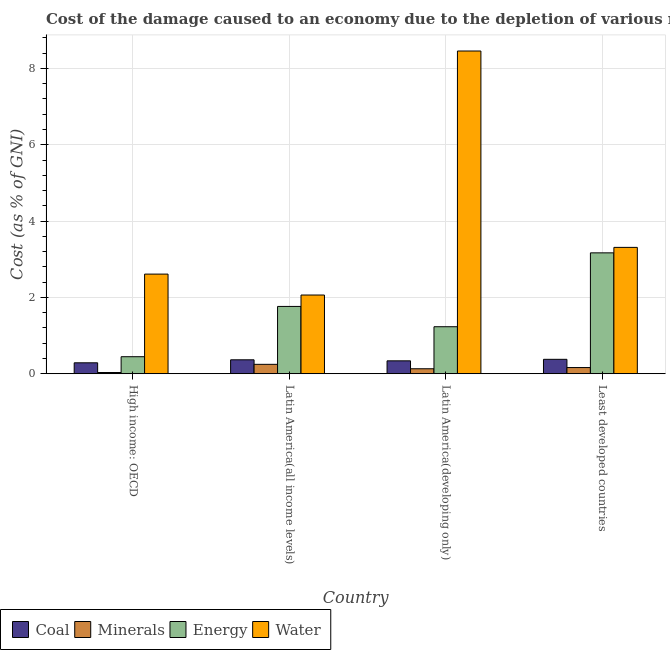How many different coloured bars are there?
Make the answer very short. 4. How many groups of bars are there?
Provide a succinct answer. 4. Are the number of bars on each tick of the X-axis equal?
Provide a short and direct response. Yes. How many bars are there on the 2nd tick from the left?
Make the answer very short. 4. How many bars are there on the 4th tick from the right?
Offer a terse response. 4. What is the label of the 2nd group of bars from the left?
Ensure brevity in your answer.  Latin America(all income levels). In how many cases, is the number of bars for a given country not equal to the number of legend labels?
Your response must be concise. 0. What is the cost of damage due to depletion of energy in Latin America(all income levels)?
Offer a very short reply. 1.76. Across all countries, what is the maximum cost of damage due to depletion of water?
Ensure brevity in your answer.  8.46. Across all countries, what is the minimum cost of damage due to depletion of minerals?
Your answer should be compact. 0.03. In which country was the cost of damage due to depletion of coal maximum?
Provide a succinct answer. Least developed countries. In which country was the cost of damage due to depletion of water minimum?
Your answer should be compact. Latin America(all income levels). What is the total cost of damage due to depletion of coal in the graph?
Offer a very short reply. 1.37. What is the difference between the cost of damage due to depletion of coal in High income: OECD and that in Least developed countries?
Provide a succinct answer. -0.09. What is the difference between the cost of damage due to depletion of minerals in Latin America(developing only) and the cost of damage due to depletion of water in Least developed countries?
Your answer should be compact. -3.18. What is the average cost of damage due to depletion of water per country?
Keep it short and to the point. 4.11. What is the difference between the cost of damage due to depletion of coal and cost of damage due to depletion of water in High income: OECD?
Your answer should be very brief. -2.32. In how many countries, is the cost of damage due to depletion of coal greater than 2 %?
Give a very brief answer. 0. What is the ratio of the cost of damage due to depletion of coal in Latin America(developing only) to that in Least developed countries?
Offer a very short reply. 0.89. What is the difference between the highest and the second highest cost of damage due to depletion of coal?
Offer a terse response. 0.01. What is the difference between the highest and the lowest cost of damage due to depletion of coal?
Your answer should be very brief. 0.09. In how many countries, is the cost of damage due to depletion of minerals greater than the average cost of damage due to depletion of minerals taken over all countries?
Offer a terse response. 2. Is it the case that in every country, the sum of the cost of damage due to depletion of coal and cost of damage due to depletion of minerals is greater than the sum of cost of damage due to depletion of energy and cost of damage due to depletion of water?
Give a very brief answer. No. What does the 3rd bar from the left in High income: OECD represents?
Keep it short and to the point. Energy. What does the 2nd bar from the right in Latin America(all income levels) represents?
Your answer should be very brief. Energy. Is it the case that in every country, the sum of the cost of damage due to depletion of coal and cost of damage due to depletion of minerals is greater than the cost of damage due to depletion of energy?
Make the answer very short. No. How many bars are there?
Your answer should be compact. 16. Does the graph contain any zero values?
Offer a very short reply. No. Where does the legend appear in the graph?
Your answer should be compact. Bottom left. How are the legend labels stacked?
Make the answer very short. Horizontal. What is the title of the graph?
Offer a terse response. Cost of the damage caused to an economy due to the depletion of various resources in 1996 . Does "Luxembourg" appear as one of the legend labels in the graph?
Your answer should be compact. No. What is the label or title of the X-axis?
Ensure brevity in your answer.  Country. What is the label or title of the Y-axis?
Your answer should be compact. Cost (as % of GNI). What is the Cost (as % of GNI) of Coal in High income: OECD?
Your answer should be very brief. 0.29. What is the Cost (as % of GNI) in Minerals in High income: OECD?
Offer a very short reply. 0.03. What is the Cost (as % of GNI) in Energy in High income: OECD?
Offer a very short reply. 0.45. What is the Cost (as % of GNI) of Water in High income: OECD?
Give a very brief answer. 2.61. What is the Cost (as % of GNI) in Coal in Latin America(all income levels)?
Make the answer very short. 0.37. What is the Cost (as % of GNI) in Minerals in Latin America(all income levels)?
Your response must be concise. 0.25. What is the Cost (as % of GNI) of Energy in Latin America(all income levels)?
Your answer should be very brief. 1.76. What is the Cost (as % of GNI) in Water in Latin America(all income levels)?
Your response must be concise. 2.06. What is the Cost (as % of GNI) of Coal in Latin America(developing only)?
Your answer should be compact. 0.34. What is the Cost (as % of GNI) of Minerals in Latin America(developing only)?
Provide a succinct answer. 0.13. What is the Cost (as % of GNI) of Energy in Latin America(developing only)?
Your response must be concise. 1.23. What is the Cost (as % of GNI) of Water in Latin America(developing only)?
Ensure brevity in your answer.  8.46. What is the Cost (as % of GNI) in Coal in Least developed countries?
Your answer should be very brief. 0.38. What is the Cost (as % of GNI) in Minerals in Least developed countries?
Your response must be concise. 0.16. What is the Cost (as % of GNI) in Energy in Least developed countries?
Provide a succinct answer. 3.17. What is the Cost (as % of GNI) in Water in Least developed countries?
Offer a very short reply. 3.31. Across all countries, what is the maximum Cost (as % of GNI) of Coal?
Provide a short and direct response. 0.38. Across all countries, what is the maximum Cost (as % of GNI) in Minerals?
Provide a succinct answer. 0.25. Across all countries, what is the maximum Cost (as % of GNI) of Energy?
Make the answer very short. 3.17. Across all countries, what is the maximum Cost (as % of GNI) of Water?
Offer a very short reply. 8.46. Across all countries, what is the minimum Cost (as % of GNI) of Coal?
Your response must be concise. 0.29. Across all countries, what is the minimum Cost (as % of GNI) in Minerals?
Offer a very short reply. 0.03. Across all countries, what is the minimum Cost (as % of GNI) of Energy?
Provide a short and direct response. 0.45. Across all countries, what is the minimum Cost (as % of GNI) in Water?
Your response must be concise. 2.06. What is the total Cost (as % of GNI) in Coal in the graph?
Offer a terse response. 1.37. What is the total Cost (as % of GNI) in Minerals in the graph?
Provide a short and direct response. 0.57. What is the total Cost (as % of GNI) in Energy in the graph?
Give a very brief answer. 6.61. What is the total Cost (as % of GNI) of Water in the graph?
Provide a succinct answer. 16.44. What is the difference between the Cost (as % of GNI) of Coal in High income: OECD and that in Latin America(all income levels)?
Offer a terse response. -0.08. What is the difference between the Cost (as % of GNI) of Minerals in High income: OECD and that in Latin America(all income levels)?
Ensure brevity in your answer.  -0.21. What is the difference between the Cost (as % of GNI) in Energy in High income: OECD and that in Latin America(all income levels)?
Your answer should be very brief. -1.32. What is the difference between the Cost (as % of GNI) of Water in High income: OECD and that in Latin America(all income levels)?
Your answer should be compact. 0.55. What is the difference between the Cost (as % of GNI) in Coal in High income: OECD and that in Latin America(developing only)?
Offer a terse response. -0.05. What is the difference between the Cost (as % of GNI) in Minerals in High income: OECD and that in Latin America(developing only)?
Offer a terse response. -0.1. What is the difference between the Cost (as % of GNI) in Energy in High income: OECD and that in Latin America(developing only)?
Your answer should be very brief. -0.79. What is the difference between the Cost (as % of GNI) in Water in High income: OECD and that in Latin America(developing only)?
Ensure brevity in your answer.  -5.85. What is the difference between the Cost (as % of GNI) in Coal in High income: OECD and that in Least developed countries?
Your answer should be compact. -0.09. What is the difference between the Cost (as % of GNI) of Minerals in High income: OECD and that in Least developed countries?
Provide a succinct answer. -0.13. What is the difference between the Cost (as % of GNI) in Energy in High income: OECD and that in Least developed countries?
Your answer should be compact. -2.72. What is the difference between the Cost (as % of GNI) of Water in High income: OECD and that in Least developed countries?
Make the answer very short. -0.7. What is the difference between the Cost (as % of GNI) of Coal in Latin America(all income levels) and that in Latin America(developing only)?
Offer a very short reply. 0.03. What is the difference between the Cost (as % of GNI) in Minerals in Latin America(all income levels) and that in Latin America(developing only)?
Your answer should be very brief. 0.12. What is the difference between the Cost (as % of GNI) of Energy in Latin America(all income levels) and that in Latin America(developing only)?
Give a very brief answer. 0.53. What is the difference between the Cost (as % of GNI) in Water in Latin America(all income levels) and that in Latin America(developing only)?
Ensure brevity in your answer.  -6.39. What is the difference between the Cost (as % of GNI) in Coal in Latin America(all income levels) and that in Least developed countries?
Your answer should be very brief. -0.01. What is the difference between the Cost (as % of GNI) of Minerals in Latin America(all income levels) and that in Least developed countries?
Your response must be concise. 0.08. What is the difference between the Cost (as % of GNI) of Energy in Latin America(all income levels) and that in Least developed countries?
Provide a succinct answer. -1.4. What is the difference between the Cost (as % of GNI) in Water in Latin America(all income levels) and that in Least developed countries?
Keep it short and to the point. -1.25. What is the difference between the Cost (as % of GNI) of Coal in Latin America(developing only) and that in Least developed countries?
Keep it short and to the point. -0.04. What is the difference between the Cost (as % of GNI) of Minerals in Latin America(developing only) and that in Least developed countries?
Your answer should be very brief. -0.03. What is the difference between the Cost (as % of GNI) of Energy in Latin America(developing only) and that in Least developed countries?
Your answer should be compact. -1.94. What is the difference between the Cost (as % of GNI) of Water in Latin America(developing only) and that in Least developed countries?
Provide a short and direct response. 5.15. What is the difference between the Cost (as % of GNI) of Coal in High income: OECD and the Cost (as % of GNI) of Minerals in Latin America(all income levels)?
Give a very brief answer. 0.04. What is the difference between the Cost (as % of GNI) of Coal in High income: OECD and the Cost (as % of GNI) of Energy in Latin America(all income levels)?
Offer a terse response. -1.48. What is the difference between the Cost (as % of GNI) in Coal in High income: OECD and the Cost (as % of GNI) in Water in Latin America(all income levels)?
Offer a very short reply. -1.78. What is the difference between the Cost (as % of GNI) in Minerals in High income: OECD and the Cost (as % of GNI) in Energy in Latin America(all income levels)?
Give a very brief answer. -1.73. What is the difference between the Cost (as % of GNI) of Minerals in High income: OECD and the Cost (as % of GNI) of Water in Latin America(all income levels)?
Provide a succinct answer. -2.03. What is the difference between the Cost (as % of GNI) in Energy in High income: OECD and the Cost (as % of GNI) in Water in Latin America(all income levels)?
Your response must be concise. -1.62. What is the difference between the Cost (as % of GNI) in Coal in High income: OECD and the Cost (as % of GNI) in Minerals in Latin America(developing only)?
Ensure brevity in your answer.  0.16. What is the difference between the Cost (as % of GNI) in Coal in High income: OECD and the Cost (as % of GNI) in Energy in Latin America(developing only)?
Your response must be concise. -0.95. What is the difference between the Cost (as % of GNI) in Coal in High income: OECD and the Cost (as % of GNI) in Water in Latin America(developing only)?
Offer a terse response. -8.17. What is the difference between the Cost (as % of GNI) in Minerals in High income: OECD and the Cost (as % of GNI) in Energy in Latin America(developing only)?
Your answer should be very brief. -1.2. What is the difference between the Cost (as % of GNI) of Minerals in High income: OECD and the Cost (as % of GNI) of Water in Latin America(developing only)?
Your response must be concise. -8.42. What is the difference between the Cost (as % of GNI) of Energy in High income: OECD and the Cost (as % of GNI) of Water in Latin America(developing only)?
Keep it short and to the point. -8.01. What is the difference between the Cost (as % of GNI) in Coal in High income: OECD and the Cost (as % of GNI) in Minerals in Least developed countries?
Offer a terse response. 0.12. What is the difference between the Cost (as % of GNI) in Coal in High income: OECD and the Cost (as % of GNI) in Energy in Least developed countries?
Provide a short and direct response. -2.88. What is the difference between the Cost (as % of GNI) of Coal in High income: OECD and the Cost (as % of GNI) of Water in Least developed countries?
Offer a very short reply. -3.02. What is the difference between the Cost (as % of GNI) in Minerals in High income: OECD and the Cost (as % of GNI) in Energy in Least developed countries?
Your response must be concise. -3.14. What is the difference between the Cost (as % of GNI) of Minerals in High income: OECD and the Cost (as % of GNI) of Water in Least developed countries?
Your answer should be compact. -3.28. What is the difference between the Cost (as % of GNI) in Energy in High income: OECD and the Cost (as % of GNI) in Water in Least developed countries?
Your response must be concise. -2.86. What is the difference between the Cost (as % of GNI) in Coal in Latin America(all income levels) and the Cost (as % of GNI) in Minerals in Latin America(developing only)?
Offer a terse response. 0.23. What is the difference between the Cost (as % of GNI) in Coal in Latin America(all income levels) and the Cost (as % of GNI) in Energy in Latin America(developing only)?
Your answer should be compact. -0.87. What is the difference between the Cost (as % of GNI) of Coal in Latin America(all income levels) and the Cost (as % of GNI) of Water in Latin America(developing only)?
Your response must be concise. -8.09. What is the difference between the Cost (as % of GNI) of Minerals in Latin America(all income levels) and the Cost (as % of GNI) of Energy in Latin America(developing only)?
Your response must be concise. -0.99. What is the difference between the Cost (as % of GNI) of Minerals in Latin America(all income levels) and the Cost (as % of GNI) of Water in Latin America(developing only)?
Ensure brevity in your answer.  -8.21. What is the difference between the Cost (as % of GNI) of Energy in Latin America(all income levels) and the Cost (as % of GNI) of Water in Latin America(developing only)?
Provide a short and direct response. -6.69. What is the difference between the Cost (as % of GNI) in Coal in Latin America(all income levels) and the Cost (as % of GNI) in Minerals in Least developed countries?
Your response must be concise. 0.2. What is the difference between the Cost (as % of GNI) in Coal in Latin America(all income levels) and the Cost (as % of GNI) in Energy in Least developed countries?
Keep it short and to the point. -2.8. What is the difference between the Cost (as % of GNI) of Coal in Latin America(all income levels) and the Cost (as % of GNI) of Water in Least developed countries?
Your response must be concise. -2.95. What is the difference between the Cost (as % of GNI) in Minerals in Latin America(all income levels) and the Cost (as % of GNI) in Energy in Least developed countries?
Give a very brief answer. -2.92. What is the difference between the Cost (as % of GNI) in Minerals in Latin America(all income levels) and the Cost (as % of GNI) in Water in Least developed countries?
Your response must be concise. -3.06. What is the difference between the Cost (as % of GNI) of Energy in Latin America(all income levels) and the Cost (as % of GNI) of Water in Least developed countries?
Your response must be concise. -1.55. What is the difference between the Cost (as % of GNI) in Coal in Latin America(developing only) and the Cost (as % of GNI) in Minerals in Least developed countries?
Provide a short and direct response. 0.18. What is the difference between the Cost (as % of GNI) of Coal in Latin America(developing only) and the Cost (as % of GNI) of Energy in Least developed countries?
Offer a very short reply. -2.83. What is the difference between the Cost (as % of GNI) of Coal in Latin America(developing only) and the Cost (as % of GNI) of Water in Least developed countries?
Give a very brief answer. -2.97. What is the difference between the Cost (as % of GNI) of Minerals in Latin America(developing only) and the Cost (as % of GNI) of Energy in Least developed countries?
Give a very brief answer. -3.04. What is the difference between the Cost (as % of GNI) in Minerals in Latin America(developing only) and the Cost (as % of GNI) in Water in Least developed countries?
Offer a terse response. -3.18. What is the difference between the Cost (as % of GNI) of Energy in Latin America(developing only) and the Cost (as % of GNI) of Water in Least developed countries?
Offer a very short reply. -2.08. What is the average Cost (as % of GNI) in Coal per country?
Make the answer very short. 0.34. What is the average Cost (as % of GNI) of Minerals per country?
Your answer should be very brief. 0.14. What is the average Cost (as % of GNI) in Energy per country?
Your answer should be compact. 1.65. What is the average Cost (as % of GNI) of Water per country?
Your answer should be very brief. 4.11. What is the difference between the Cost (as % of GNI) in Coal and Cost (as % of GNI) in Minerals in High income: OECD?
Your answer should be very brief. 0.25. What is the difference between the Cost (as % of GNI) in Coal and Cost (as % of GNI) in Energy in High income: OECD?
Give a very brief answer. -0.16. What is the difference between the Cost (as % of GNI) in Coal and Cost (as % of GNI) in Water in High income: OECD?
Your answer should be very brief. -2.32. What is the difference between the Cost (as % of GNI) of Minerals and Cost (as % of GNI) of Energy in High income: OECD?
Provide a succinct answer. -0.41. What is the difference between the Cost (as % of GNI) in Minerals and Cost (as % of GNI) in Water in High income: OECD?
Offer a terse response. -2.58. What is the difference between the Cost (as % of GNI) of Energy and Cost (as % of GNI) of Water in High income: OECD?
Provide a succinct answer. -2.16. What is the difference between the Cost (as % of GNI) of Coal and Cost (as % of GNI) of Minerals in Latin America(all income levels)?
Provide a succinct answer. 0.12. What is the difference between the Cost (as % of GNI) of Coal and Cost (as % of GNI) of Energy in Latin America(all income levels)?
Your response must be concise. -1.4. What is the difference between the Cost (as % of GNI) of Coal and Cost (as % of GNI) of Water in Latin America(all income levels)?
Keep it short and to the point. -1.7. What is the difference between the Cost (as % of GNI) in Minerals and Cost (as % of GNI) in Energy in Latin America(all income levels)?
Your answer should be very brief. -1.52. What is the difference between the Cost (as % of GNI) in Minerals and Cost (as % of GNI) in Water in Latin America(all income levels)?
Ensure brevity in your answer.  -1.82. What is the difference between the Cost (as % of GNI) of Energy and Cost (as % of GNI) of Water in Latin America(all income levels)?
Your answer should be compact. -0.3. What is the difference between the Cost (as % of GNI) in Coal and Cost (as % of GNI) in Minerals in Latin America(developing only)?
Provide a short and direct response. 0.21. What is the difference between the Cost (as % of GNI) of Coal and Cost (as % of GNI) of Energy in Latin America(developing only)?
Your answer should be very brief. -0.89. What is the difference between the Cost (as % of GNI) of Coal and Cost (as % of GNI) of Water in Latin America(developing only)?
Keep it short and to the point. -8.12. What is the difference between the Cost (as % of GNI) of Minerals and Cost (as % of GNI) of Energy in Latin America(developing only)?
Ensure brevity in your answer.  -1.1. What is the difference between the Cost (as % of GNI) in Minerals and Cost (as % of GNI) in Water in Latin America(developing only)?
Ensure brevity in your answer.  -8.33. What is the difference between the Cost (as % of GNI) of Energy and Cost (as % of GNI) of Water in Latin America(developing only)?
Make the answer very short. -7.22. What is the difference between the Cost (as % of GNI) of Coal and Cost (as % of GNI) of Minerals in Least developed countries?
Make the answer very short. 0.22. What is the difference between the Cost (as % of GNI) in Coal and Cost (as % of GNI) in Energy in Least developed countries?
Give a very brief answer. -2.79. What is the difference between the Cost (as % of GNI) of Coal and Cost (as % of GNI) of Water in Least developed countries?
Your answer should be very brief. -2.93. What is the difference between the Cost (as % of GNI) of Minerals and Cost (as % of GNI) of Energy in Least developed countries?
Provide a succinct answer. -3.01. What is the difference between the Cost (as % of GNI) of Minerals and Cost (as % of GNI) of Water in Least developed countries?
Give a very brief answer. -3.15. What is the difference between the Cost (as % of GNI) in Energy and Cost (as % of GNI) in Water in Least developed countries?
Make the answer very short. -0.14. What is the ratio of the Cost (as % of GNI) in Coal in High income: OECD to that in Latin America(all income levels)?
Make the answer very short. 0.78. What is the ratio of the Cost (as % of GNI) of Minerals in High income: OECD to that in Latin America(all income levels)?
Your response must be concise. 0.13. What is the ratio of the Cost (as % of GNI) in Energy in High income: OECD to that in Latin America(all income levels)?
Make the answer very short. 0.25. What is the ratio of the Cost (as % of GNI) in Water in High income: OECD to that in Latin America(all income levels)?
Make the answer very short. 1.27. What is the ratio of the Cost (as % of GNI) of Coal in High income: OECD to that in Latin America(developing only)?
Your answer should be compact. 0.85. What is the ratio of the Cost (as % of GNI) in Minerals in High income: OECD to that in Latin America(developing only)?
Provide a short and direct response. 0.25. What is the ratio of the Cost (as % of GNI) of Energy in High income: OECD to that in Latin America(developing only)?
Your answer should be compact. 0.36. What is the ratio of the Cost (as % of GNI) of Water in High income: OECD to that in Latin America(developing only)?
Your answer should be compact. 0.31. What is the ratio of the Cost (as % of GNI) of Coal in High income: OECD to that in Least developed countries?
Ensure brevity in your answer.  0.76. What is the ratio of the Cost (as % of GNI) in Minerals in High income: OECD to that in Least developed countries?
Keep it short and to the point. 0.2. What is the ratio of the Cost (as % of GNI) in Energy in High income: OECD to that in Least developed countries?
Keep it short and to the point. 0.14. What is the ratio of the Cost (as % of GNI) in Water in High income: OECD to that in Least developed countries?
Your response must be concise. 0.79. What is the ratio of the Cost (as % of GNI) of Coal in Latin America(all income levels) to that in Latin America(developing only)?
Keep it short and to the point. 1.08. What is the ratio of the Cost (as % of GNI) of Minerals in Latin America(all income levels) to that in Latin America(developing only)?
Provide a short and direct response. 1.89. What is the ratio of the Cost (as % of GNI) in Energy in Latin America(all income levels) to that in Latin America(developing only)?
Make the answer very short. 1.43. What is the ratio of the Cost (as % of GNI) of Water in Latin America(all income levels) to that in Latin America(developing only)?
Your response must be concise. 0.24. What is the ratio of the Cost (as % of GNI) of Coal in Latin America(all income levels) to that in Least developed countries?
Provide a short and direct response. 0.97. What is the ratio of the Cost (as % of GNI) of Minerals in Latin America(all income levels) to that in Least developed countries?
Give a very brief answer. 1.52. What is the ratio of the Cost (as % of GNI) of Energy in Latin America(all income levels) to that in Least developed countries?
Keep it short and to the point. 0.56. What is the ratio of the Cost (as % of GNI) in Water in Latin America(all income levels) to that in Least developed countries?
Your answer should be compact. 0.62. What is the ratio of the Cost (as % of GNI) in Coal in Latin America(developing only) to that in Least developed countries?
Ensure brevity in your answer.  0.89. What is the ratio of the Cost (as % of GNI) of Minerals in Latin America(developing only) to that in Least developed countries?
Ensure brevity in your answer.  0.81. What is the ratio of the Cost (as % of GNI) of Energy in Latin America(developing only) to that in Least developed countries?
Your response must be concise. 0.39. What is the ratio of the Cost (as % of GNI) of Water in Latin America(developing only) to that in Least developed countries?
Offer a terse response. 2.55. What is the difference between the highest and the second highest Cost (as % of GNI) of Coal?
Offer a terse response. 0.01. What is the difference between the highest and the second highest Cost (as % of GNI) in Minerals?
Keep it short and to the point. 0.08. What is the difference between the highest and the second highest Cost (as % of GNI) of Energy?
Offer a very short reply. 1.4. What is the difference between the highest and the second highest Cost (as % of GNI) of Water?
Give a very brief answer. 5.15. What is the difference between the highest and the lowest Cost (as % of GNI) in Coal?
Your answer should be compact. 0.09. What is the difference between the highest and the lowest Cost (as % of GNI) of Minerals?
Offer a terse response. 0.21. What is the difference between the highest and the lowest Cost (as % of GNI) in Energy?
Keep it short and to the point. 2.72. What is the difference between the highest and the lowest Cost (as % of GNI) in Water?
Offer a very short reply. 6.39. 